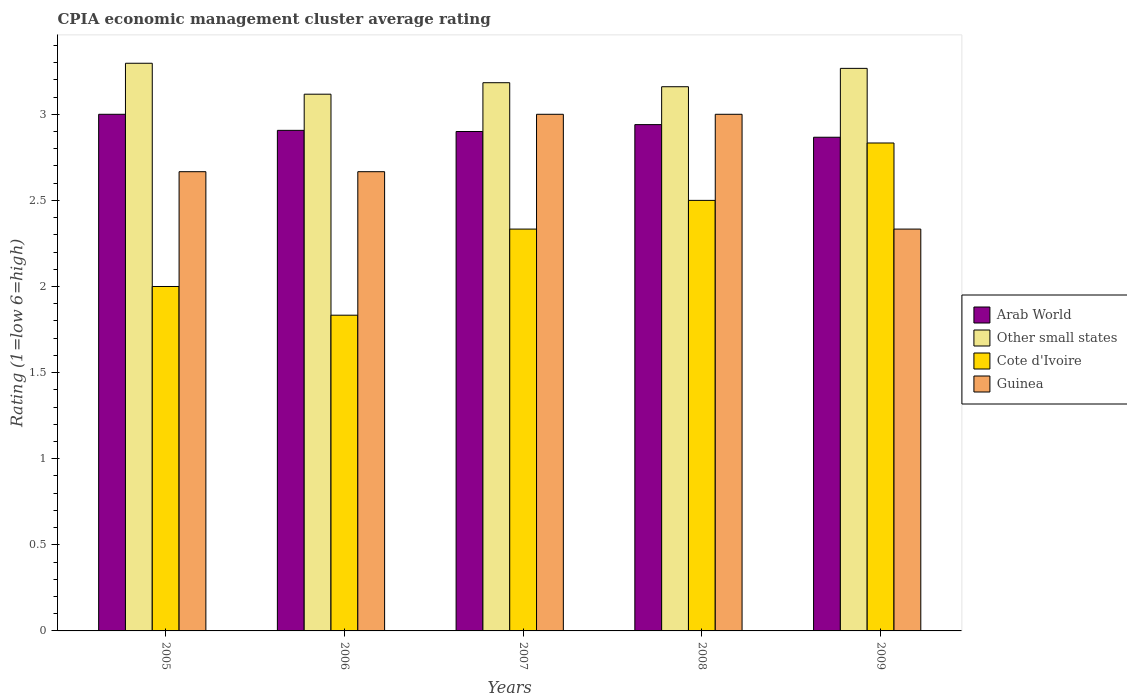How many different coloured bars are there?
Offer a terse response. 4. How many groups of bars are there?
Ensure brevity in your answer.  5. Are the number of bars on each tick of the X-axis equal?
Offer a very short reply. Yes. How many bars are there on the 1st tick from the left?
Ensure brevity in your answer.  4. What is the label of the 1st group of bars from the left?
Make the answer very short. 2005. In how many cases, is the number of bars for a given year not equal to the number of legend labels?
Make the answer very short. 0. What is the CPIA rating in Cote d'Ivoire in 2008?
Ensure brevity in your answer.  2.5. Across all years, what is the minimum CPIA rating in Cote d'Ivoire?
Your response must be concise. 1.83. In which year was the CPIA rating in Other small states minimum?
Provide a short and direct response. 2006. What is the total CPIA rating in Arab World in the graph?
Your answer should be very brief. 14.61. What is the difference between the CPIA rating in Cote d'Ivoire in 2005 and that in 2006?
Keep it short and to the point. 0.17. What is the difference between the CPIA rating in Cote d'Ivoire in 2005 and the CPIA rating in Other small states in 2009?
Your response must be concise. -1.27. What is the average CPIA rating in Cote d'Ivoire per year?
Provide a succinct answer. 2.3. In the year 2007, what is the difference between the CPIA rating in Cote d'Ivoire and CPIA rating in Arab World?
Give a very brief answer. -0.57. In how many years, is the CPIA rating in Guinea greater than 2.4?
Offer a very short reply. 4. What is the ratio of the CPIA rating in Guinea in 2005 to that in 2007?
Give a very brief answer. 0.89. What is the difference between the highest and the second highest CPIA rating in Other small states?
Your answer should be compact. 0.03. What is the difference between the highest and the lowest CPIA rating in Guinea?
Give a very brief answer. 0.67. Is the sum of the CPIA rating in Guinea in 2008 and 2009 greater than the maximum CPIA rating in Cote d'Ivoire across all years?
Make the answer very short. Yes. What does the 4th bar from the left in 2005 represents?
Provide a succinct answer. Guinea. What does the 3rd bar from the right in 2006 represents?
Make the answer very short. Other small states. Is it the case that in every year, the sum of the CPIA rating in Cote d'Ivoire and CPIA rating in Arab World is greater than the CPIA rating in Guinea?
Make the answer very short. Yes. How many bars are there?
Keep it short and to the point. 20. Are all the bars in the graph horizontal?
Your answer should be very brief. No. What is the difference between two consecutive major ticks on the Y-axis?
Ensure brevity in your answer.  0.5. Does the graph contain any zero values?
Make the answer very short. No. Does the graph contain grids?
Your response must be concise. No. How many legend labels are there?
Provide a succinct answer. 4. What is the title of the graph?
Keep it short and to the point. CPIA economic management cluster average rating. Does "Bermuda" appear as one of the legend labels in the graph?
Offer a very short reply. No. What is the label or title of the Y-axis?
Ensure brevity in your answer.  Rating (1=low 6=high). What is the Rating (1=low 6=high) in Arab World in 2005?
Your answer should be very brief. 3. What is the Rating (1=low 6=high) in Other small states in 2005?
Provide a short and direct response. 3.3. What is the Rating (1=low 6=high) in Guinea in 2005?
Provide a succinct answer. 2.67. What is the Rating (1=low 6=high) of Arab World in 2006?
Offer a terse response. 2.91. What is the Rating (1=low 6=high) in Other small states in 2006?
Make the answer very short. 3.12. What is the Rating (1=low 6=high) of Cote d'Ivoire in 2006?
Offer a very short reply. 1.83. What is the Rating (1=low 6=high) in Guinea in 2006?
Your answer should be compact. 2.67. What is the Rating (1=low 6=high) in Other small states in 2007?
Offer a terse response. 3.18. What is the Rating (1=low 6=high) in Cote d'Ivoire in 2007?
Keep it short and to the point. 2.33. What is the Rating (1=low 6=high) in Guinea in 2007?
Your answer should be very brief. 3. What is the Rating (1=low 6=high) of Arab World in 2008?
Give a very brief answer. 2.94. What is the Rating (1=low 6=high) of Other small states in 2008?
Offer a very short reply. 3.16. What is the Rating (1=low 6=high) in Arab World in 2009?
Give a very brief answer. 2.87. What is the Rating (1=low 6=high) in Other small states in 2009?
Keep it short and to the point. 3.27. What is the Rating (1=low 6=high) of Cote d'Ivoire in 2009?
Your answer should be compact. 2.83. What is the Rating (1=low 6=high) of Guinea in 2009?
Ensure brevity in your answer.  2.33. Across all years, what is the maximum Rating (1=low 6=high) in Other small states?
Offer a terse response. 3.3. Across all years, what is the maximum Rating (1=low 6=high) of Cote d'Ivoire?
Ensure brevity in your answer.  2.83. Across all years, what is the maximum Rating (1=low 6=high) of Guinea?
Your response must be concise. 3. Across all years, what is the minimum Rating (1=low 6=high) of Arab World?
Provide a short and direct response. 2.87. Across all years, what is the minimum Rating (1=low 6=high) in Other small states?
Provide a short and direct response. 3.12. Across all years, what is the minimum Rating (1=low 6=high) in Cote d'Ivoire?
Offer a very short reply. 1.83. Across all years, what is the minimum Rating (1=low 6=high) in Guinea?
Give a very brief answer. 2.33. What is the total Rating (1=low 6=high) in Arab World in the graph?
Make the answer very short. 14.61. What is the total Rating (1=low 6=high) of Other small states in the graph?
Your answer should be compact. 16.02. What is the total Rating (1=low 6=high) of Cote d'Ivoire in the graph?
Your answer should be compact. 11.5. What is the total Rating (1=low 6=high) in Guinea in the graph?
Ensure brevity in your answer.  13.67. What is the difference between the Rating (1=low 6=high) in Arab World in 2005 and that in 2006?
Your response must be concise. 0.09. What is the difference between the Rating (1=low 6=high) in Other small states in 2005 and that in 2006?
Your answer should be very brief. 0.18. What is the difference between the Rating (1=low 6=high) in Arab World in 2005 and that in 2007?
Offer a very short reply. 0.1. What is the difference between the Rating (1=low 6=high) in Other small states in 2005 and that in 2007?
Give a very brief answer. 0.11. What is the difference between the Rating (1=low 6=high) in Cote d'Ivoire in 2005 and that in 2007?
Your answer should be very brief. -0.33. What is the difference between the Rating (1=low 6=high) in Guinea in 2005 and that in 2007?
Keep it short and to the point. -0.33. What is the difference between the Rating (1=low 6=high) of Arab World in 2005 and that in 2008?
Give a very brief answer. 0.06. What is the difference between the Rating (1=low 6=high) of Other small states in 2005 and that in 2008?
Provide a short and direct response. 0.14. What is the difference between the Rating (1=low 6=high) in Arab World in 2005 and that in 2009?
Keep it short and to the point. 0.13. What is the difference between the Rating (1=low 6=high) of Other small states in 2005 and that in 2009?
Offer a terse response. 0.03. What is the difference between the Rating (1=low 6=high) in Guinea in 2005 and that in 2009?
Provide a succinct answer. 0.33. What is the difference between the Rating (1=low 6=high) in Arab World in 2006 and that in 2007?
Your answer should be very brief. 0.01. What is the difference between the Rating (1=low 6=high) of Other small states in 2006 and that in 2007?
Your answer should be very brief. -0.07. What is the difference between the Rating (1=low 6=high) in Guinea in 2006 and that in 2007?
Give a very brief answer. -0.33. What is the difference between the Rating (1=low 6=high) of Arab World in 2006 and that in 2008?
Make the answer very short. -0.03. What is the difference between the Rating (1=low 6=high) in Other small states in 2006 and that in 2008?
Keep it short and to the point. -0.04. What is the difference between the Rating (1=low 6=high) in Other small states in 2006 and that in 2009?
Give a very brief answer. -0.15. What is the difference between the Rating (1=low 6=high) in Cote d'Ivoire in 2006 and that in 2009?
Your answer should be very brief. -1. What is the difference between the Rating (1=low 6=high) in Guinea in 2006 and that in 2009?
Offer a terse response. 0.33. What is the difference between the Rating (1=low 6=high) of Arab World in 2007 and that in 2008?
Make the answer very short. -0.04. What is the difference between the Rating (1=low 6=high) in Other small states in 2007 and that in 2008?
Provide a short and direct response. 0.02. What is the difference between the Rating (1=low 6=high) of Arab World in 2007 and that in 2009?
Your answer should be very brief. 0.03. What is the difference between the Rating (1=low 6=high) in Other small states in 2007 and that in 2009?
Provide a succinct answer. -0.08. What is the difference between the Rating (1=low 6=high) in Arab World in 2008 and that in 2009?
Provide a succinct answer. 0.07. What is the difference between the Rating (1=low 6=high) of Other small states in 2008 and that in 2009?
Give a very brief answer. -0.11. What is the difference between the Rating (1=low 6=high) of Cote d'Ivoire in 2008 and that in 2009?
Provide a short and direct response. -0.33. What is the difference between the Rating (1=low 6=high) of Guinea in 2008 and that in 2009?
Your answer should be compact. 0.67. What is the difference between the Rating (1=low 6=high) in Arab World in 2005 and the Rating (1=low 6=high) in Other small states in 2006?
Your answer should be compact. -0.12. What is the difference between the Rating (1=low 6=high) of Other small states in 2005 and the Rating (1=low 6=high) of Cote d'Ivoire in 2006?
Provide a succinct answer. 1.46. What is the difference between the Rating (1=low 6=high) in Other small states in 2005 and the Rating (1=low 6=high) in Guinea in 2006?
Offer a terse response. 0.63. What is the difference between the Rating (1=low 6=high) in Arab World in 2005 and the Rating (1=low 6=high) in Other small states in 2007?
Make the answer very short. -0.18. What is the difference between the Rating (1=low 6=high) in Other small states in 2005 and the Rating (1=low 6=high) in Cote d'Ivoire in 2007?
Provide a succinct answer. 0.96. What is the difference between the Rating (1=low 6=high) of Other small states in 2005 and the Rating (1=low 6=high) of Guinea in 2007?
Make the answer very short. 0.3. What is the difference between the Rating (1=low 6=high) of Cote d'Ivoire in 2005 and the Rating (1=low 6=high) of Guinea in 2007?
Provide a short and direct response. -1. What is the difference between the Rating (1=low 6=high) in Arab World in 2005 and the Rating (1=low 6=high) in Other small states in 2008?
Give a very brief answer. -0.16. What is the difference between the Rating (1=low 6=high) in Arab World in 2005 and the Rating (1=low 6=high) in Guinea in 2008?
Keep it short and to the point. 0. What is the difference between the Rating (1=low 6=high) of Other small states in 2005 and the Rating (1=low 6=high) of Cote d'Ivoire in 2008?
Your answer should be compact. 0.8. What is the difference between the Rating (1=low 6=high) of Other small states in 2005 and the Rating (1=low 6=high) of Guinea in 2008?
Make the answer very short. 0.3. What is the difference between the Rating (1=low 6=high) in Arab World in 2005 and the Rating (1=low 6=high) in Other small states in 2009?
Your answer should be compact. -0.27. What is the difference between the Rating (1=low 6=high) of Other small states in 2005 and the Rating (1=low 6=high) of Cote d'Ivoire in 2009?
Ensure brevity in your answer.  0.46. What is the difference between the Rating (1=low 6=high) of Cote d'Ivoire in 2005 and the Rating (1=low 6=high) of Guinea in 2009?
Give a very brief answer. -0.33. What is the difference between the Rating (1=low 6=high) of Arab World in 2006 and the Rating (1=low 6=high) of Other small states in 2007?
Your answer should be compact. -0.28. What is the difference between the Rating (1=low 6=high) of Arab World in 2006 and the Rating (1=low 6=high) of Cote d'Ivoire in 2007?
Make the answer very short. 0.57. What is the difference between the Rating (1=low 6=high) of Arab World in 2006 and the Rating (1=low 6=high) of Guinea in 2007?
Offer a terse response. -0.09. What is the difference between the Rating (1=low 6=high) in Other small states in 2006 and the Rating (1=low 6=high) in Cote d'Ivoire in 2007?
Offer a terse response. 0.78. What is the difference between the Rating (1=low 6=high) in Other small states in 2006 and the Rating (1=low 6=high) in Guinea in 2007?
Ensure brevity in your answer.  0.12. What is the difference between the Rating (1=low 6=high) in Cote d'Ivoire in 2006 and the Rating (1=low 6=high) in Guinea in 2007?
Offer a terse response. -1.17. What is the difference between the Rating (1=low 6=high) of Arab World in 2006 and the Rating (1=low 6=high) of Other small states in 2008?
Your response must be concise. -0.25. What is the difference between the Rating (1=low 6=high) of Arab World in 2006 and the Rating (1=low 6=high) of Cote d'Ivoire in 2008?
Give a very brief answer. 0.41. What is the difference between the Rating (1=low 6=high) in Arab World in 2006 and the Rating (1=low 6=high) in Guinea in 2008?
Your answer should be very brief. -0.09. What is the difference between the Rating (1=low 6=high) in Other small states in 2006 and the Rating (1=low 6=high) in Cote d'Ivoire in 2008?
Ensure brevity in your answer.  0.62. What is the difference between the Rating (1=low 6=high) in Other small states in 2006 and the Rating (1=low 6=high) in Guinea in 2008?
Your answer should be very brief. 0.12. What is the difference between the Rating (1=low 6=high) of Cote d'Ivoire in 2006 and the Rating (1=low 6=high) of Guinea in 2008?
Your answer should be compact. -1.17. What is the difference between the Rating (1=low 6=high) of Arab World in 2006 and the Rating (1=low 6=high) of Other small states in 2009?
Your response must be concise. -0.36. What is the difference between the Rating (1=low 6=high) of Arab World in 2006 and the Rating (1=low 6=high) of Cote d'Ivoire in 2009?
Your answer should be compact. 0.07. What is the difference between the Rating (1=low 6=high) in Arab World in 2006 and the Rating (1=low 6=high) in Guinea in 2009?
Provide a succinct answer. 0.57. What is the difference between the Rating (1=low 6=high) in Other small states in 2006 and the Rating (1=low 6=high) in Cote d'Ivoire in 2009?
Offer a very short reply. 0.28. What is the difference between the Rating (1=low 6=high) of Other small states in 2006 and the Rating (1=low 6=high) of Guinea in 2009?
Your answer should be compact. 0.78. What is the difference between the Rating (1=low 6=high) in Arab World in 2007 and the Rating (1=low 6=high) in Other small states in 2008?
Make the answer very short. -0.26. What is the difference between the Rating (1=low 6=high) in Arab World in 2007 and the Rating (1=low 6=high) in Cote d'Ivoire in 2008?
Make the answer very short. 0.4. What is the difference between the Rating (1=low 6=high) of Arab World in 2007 and the Rating (1=low 6=high) of Guinea in 2008?
Your response must be concise. -0.1. What is the difference between the Rating (1=low 6=high) in Other small states in 2007 and the Rating (1=low 6=high) in Cote d'Ivoire in 2008?
Your answer should be compact. 0.68. What is the difference between the Rating (1=low 6=high) in Other small states in 2007 and the Rating (1=low 6=high) in Guinea in 2008?
Offer a terse response. 0.18. What is the difference between the Rating (1=low 6=high) of Cote d'Ivoire in 2007 and the Rating (1=low 6=high) of Guinea in 2008?
Provide a short and direct response. -0.67. What is the difference between the Rating (1=low 6=high) in Arab World in 2007 and the Rating (1=low 6=high) in Other small states in 2009?
Your answer should be very brief. -0.37. What is the difference between the Rating (1=low 6=high) of Arab World in 2007 and the Rating (1=low 6=high) of Cote d'Ivoire in 2009?
Keep it short and to the point. 0.07. What is the difference between the Rating (1=low 6=high) of Arab World in 2007 and the Rating (1=low 6=high) of Guinea in 2009?
Offer a terse response. 0.57. What is the difference between the Rating (1=low 6=high) of Cote d'Ivoire in 2007 and the Rating (1=low 6=high) of Guinea in 2009?
Give a very brief answer. 0. What is the difference between the Rating (1=low 6=high) in Arab World in 2008 and the Rating (1=low 6=high) in Other small states in 2009?
Your answer should be very brief. -0.33. What is the difference between the Rating (1=low 6=high) in Arab World in 2008 and the Rating (1=low 6=high) in Cote d'Ivoire in 2009?
Provide a succinct answer. 0.11. What is the difference between the Rating (1=low 6=high) in Arab World in 2008 and the Rating (1=low 6=high) in Guinea in 2009?
Offer a very short reply. 0.61. What is the difference between the Rating (1=low 6=high) of Other small states in 2008 and the Rating (1=low 6=high) of Cote d'Ivoire in 2009?
Give a very brief answer. 0.33. What is the difference between the Rating (1=low 6=high) of Other small states in 2008 and the Rating (1=low 6=high) of Guinea in 2009?
Offer a terse response. 0.83. What is the average Rating (1=low 6=high) in Arab World per year?
Your answer should be compact. 2.92. What is the average Rating (1=low 6=high) in Other small states per year?
Make the answer very short. 3.2. What is the average Rating (1=low 6=high) in Guinea per year?
Offer a terse response. 2.73. In the year 2005, what is the difference between the Rating (1=low 6=high) of Arab World and Rating (1=low 6=high) of Other small states?
Provide a succinct answer. -0.3. In the year 2005, what is the difference between the Rating (1=low 6=high) in Arab World and Rating (1=low 6=high) in Cote d'Ivoire?
Give a very brief answer. 1. In the year 2005, what is the difference between the Rating (1=low 6=high) in Arab World and Rating (1=low 6=high) in Guinea?
Provide a succinct answer. 0.33. In the year 2005, what is the difference between the Rating (1=low 6=high) in Other small states and Rating (1=low 6=high) in Cote d'Ivoire?
Provide a succinct answer. 1.3. In the year 2005, what is the difference between the Rating (1=low 6=high) in Other small states and Rating (1=low 6=high) in Guinea?
Your answer should be compact. 0.63. In the year 2005, what is the difference between the Rating (1=low 6=high) of Cote d'Ivoire and Rating (1=low 6=high) of Guinea?
Provide a short and direct response. -0.67. In the year 2006, what is the difference between the Rating (1=low 6=high) in Arab World and Rating (1=low 6=high) in Other small states?
Your answer should be very brief. -0.21. In the year 2006, what is the difference between the Rating (1=low 6=high) of Arab World and Rating (1=low 6=high) of Cote d'Ivoire?
Your response must be concise. 1.07. In the year 2006, what is the difference between the Rating (1=low 6=high) in Arab World and Rating (1=low 6=high) in Guinea?
Make the answer very short. 0.24. In the year 2006, what is the difference between the Rating (1=low 6=high) of Other small states and Rating (1=low 6=high) of Cote d'Ivoire?
Provide a short and direct response. 1.28. In the year 2006, what is the difference between the Rating (1=low 6=high) of Other small states and Rating (1=low 6=high) of Guinea?
Provide a succinct answer. 0.45. In the year 2007, what is the difference between the Rating (1=low 6=high) of Arab World and Rating (1=low 6=high) of Other small states?
Offer a very short reply. -0.28. In the year 2007, what is the difference between the Rating (1=low 6=high) in Arab World and Rating (1=low 6=high) in Cote d'Ivoire?
Provide a succinct answer. 0.57. In the year 2007, what is the difference between the Rating (1=low 6=high) of Other small states and Rating (1=low 6=high) of Cote d'Ivoire?
Provide a succinct answer. 0.85. In the year 2007, what is the difference between the Rating (1=low 6=high) of Other small states and Rating (1=low 6=high) of Guinea?
Offer a very short reply. 0.18. In the year 2007, what is the difference between the Rating (1=low 6=high) in Cote d'Ivoire and Rating (1=low 6=high) in Guinea?
Your response must be concise. -0.67. In the year 2008, what is the difference between the Rating (1=low 6=high) in Arab World and Rating (1=low 6=high) in Other small states?
Your answer should be compact. -0.22. In the year 2008, what is the difference between the Rating (1=low 6=high) in Arab World and Rating (1=low 6=high) in Cote d'Ivoire?
Provide a succinct answer. 0.44. In the year 2008, what is the difference between the Rating (1=low 6=high) in Arab World and Rating (1=low 6=high) in Guinea?
Your response must be concise. -0.06. In the year 2008, what is the difference between the Rating (1=low 6=high) in Other small states and Rating (1=low 6=high) in Cote d'Ivoire?
Your answer should be very brief. 0.66. In the year 2008, what is the difference between the Rating (1=low 6=high) in Other small states and Rating (1=low 6=high) in Guinea?
Your response must be concise. 0.16. In the year 2008, what is the difference between the Rating (1=low 6=high) of Cote d'Ivoire and Rating (1=low 6=high) of Guinea?
Ensure brevity in your answer.  -0.5. In the year 2009, what is the difference between the Rating (1=low 6=high) of Arab World and Rating (1=low 6=high) of Other small states?
Your answer should be compact. -0.4. In the year 2009, what is the difference between the Rating (1=low 6=high) in Arab World and Rating (1=low 6=high) in Guinea?
Your response must be concise. 0.53. In the year 2009, what is the difference between the Rating (1=low 6=high) in Other small states and Rating (1=low 6=high) in Cote d'Ivoire?
Offer a very short reply. 0.43. In the year 2009, what is the difference between the Rating (1=low 6=high) of Other small states and Rating (1=low 6=high) of Guinea?
Ensure brevity in your answer.  0.93. What is the ratio of the Rating (1=low 6=high) in Arab World in 2005 to that in 2006?
Your answer should be compact. 1.03. What is the ratio of the Rating (1=low 6=high) in Other small states in 2005 to that in 2006?
Your answer should be compact. 1.06. What is the ratio of the Rating (1=low 6=high) in Cote d'Ivoire in 2005 to that in 2006?
Your answer should be compact. 1.09. What is the ratio of the Rating (1=low 6=high) of Guinea in 2005 to that in 2006?
Offer a terse response. 1. What is the ratio of the Rating (1=low 6=high) in Arab World in 2005 to that in 2007?
Ensure brevity in your answer.  1.03. What is the ratio of the Rating (1=low 6=high) in Other small states in 2005 to that in 2007?
Provide a succinct answer. 1.04. What is the ratio of the Rating (1=low 6=high) in Arab World in 2005 to that in 2008?
Your answer should be very brief. 1.02. What is the ratio of the Rating (1=low 6=high) of Other small states in 2005 to that in 2008?
Provide a short and direct response. 1.04. What is the ratio of the Rating (1=low 6=high) of Cote d'Ivoire in 2005 to that in 2008?
Your response must be concise. 0.8. What is the ratio of the Rating (1=low 6=high) in Arab World in 2005 to that in 2009?
Your answer should be very brief. 1.05. What is the ratio of the Rating (1=low 6=high) in Other small states in 2005 to that in 2009?
Give a very brief answer. 1.01. What is the ratio of the Rating (1=low 6=high) of Cote d'Ivoire in 2005 to that in 2009?
Keep it short and to the point. 0.71. What is the ratio of the Rating (1=low 6=high) in Guinea in 2005 to that in 2009?
Make the answer very short. 1.14. What is the ratio of the Rating (1=low 6=high) of Other small states in 2006 to that in 2007?
Provide a short and direct response. 0.98. What is the ratio of the Rating (1=low 6=high) in Cote d'Ivoire in 2006 to that in 2007?
Provide a short and direct response. 0.79. What is the ratio of the Rating (1=low 6=high) in Arab World in 2006 to that in 2008?
Offer a terse response. 0.99. What is the ratio of the Rating (1=low 6=high) of Other small states in 2006 to that in 2008?
Provide a succinct answer. 0.99. What is the ratio of the Rating (1=low 6=high) of Cote d'Ivoire in 2006 to that in 2008?
Keep it short and to the point. 0.73. What is the ratio of the Rating (1=low 6=high) in Guinea in 2006 to that in 2008?
Provide a succinct answer. 0.89. What is the ratio of the Rating (1=low 6=high) of Arab World in 2006 to that in 2009?
Keep it short and to the point. 1.01. What is the ratio of the Rating (1=low 6=high) in Other small states in 2006 to that in 2009?
Provide a succinct answer. 0.95. What is the ratio of the Rating (1=low 6=high) in Cote d'Ivoire in 2006 to that in 2009?
Your response must be concise. 0.65. What is the ratio of the Rating (1=low 6=high) of Guinea in 2006 to that in 2009?
Your answer should be very brief. 1.14. What is the ratio of the Rating (1=low 6=high) of Arab World in 2007 to that in 2008?
Your response must be concise. 0.99. What is the ratio of the Rating (1=low 6=high) of Other small states in 2007 to that in 2008?
Offer a very short reply. 1.01. What is the ratio of the Rating (1=low 6=high) in Cote d'Ivoire in 2007 to that in 2008?
Provide a succinct answer. 0.93. What is the ratio of the Rating (1=low 6=high) of Arab World in 2007 to that in 2009?
Provide a succinct answer. 1.01. What is the ratio of the Rating (1=low 6=high) in Other small states in 2007 to that in 2009?
Make the answer very short. 0.97. What is the ratio of the Rating (1=low 6=high) in Cote d'Ivoire in 2007 to that in 2009?
Provide a short and direct response. 0.82. What is the ratio of the Rating (1=low 6=high) in Arab World in 2008 to that in 2009?
Make the answer very short. 1.03. What is the ratio of the Rating (1=low 6=high) in Other small states in 2008 to that in 2009?
Give a very brief answer. 0.97. What is the ratio of the Rating (1=low 6=high) of Cote d'Ivoire in 2008 to that in 2009?
Provide a short and direct response. 0.88. What is the difference between the highest and the second highest Rating (1=low 6=high) in Other small states?
Your response must be concise. 0.03. What is the difference between the highest and the lowest Rating (1=low 6=high) of Arab World?
Your response must be concise. 0.13. What is the difference between the highest and the lowest Rating (1=low 6=high) in Other small states?
Your response must be concise. 0.18. What is the difference between the highest and the lowest Rating (1=low 6=high) in Guinea?
Keep it short and to the point. 0.67. 